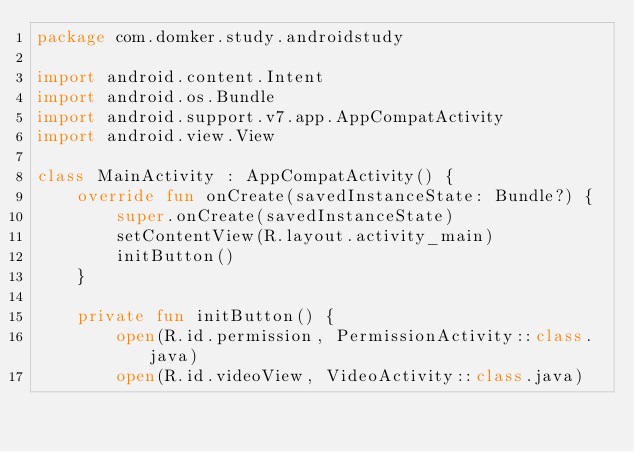<code> <loc_0><loc_0><loc_500><loc_500><_Kotlin_>package com.domker.study.androidstudy

import android.content.Intent
import android.os.Bundle
import android.support.v7.app.AppCompatActivity
import android.view.View

class MainActivity : AppCompatActivity() {
    override fun onCreate(savedInstanceState: Bundle?) {
        super.onCreate(savedInstanceState)
        setContentView(R.layout.activity_main)
        initButton()
    }

    private fun initButton() {
        open(R.id.permission, PermissionActivity::class.java)
        open(R.id.videoView, VideoActivity::class.java)</code> 